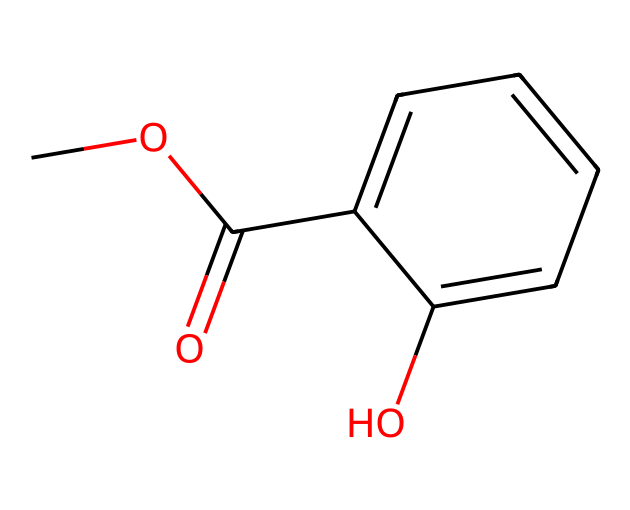How many carbon atoms are present in methyl salicylate? The SMILES representation indicates that there are six carbon atoms in the overall structure. Each "C" represents a carbon atom, and counting them results in a total of six.
Answer: six What functional groups are present in methyl salicylate? Upon analyzing the structure, we can see that there is an ester group (indicated by the COO link) and a hydroxyl group (–OH) stemming from the aromatic ring, classifying it as a phenolic compound as well.
Answer: ester and hydroxyl How many oxygen atoms are in methyl salicylate? The SMILES representation includes the letters "O" which represent oxygen atoms. In this case, there are two oxygen atoms present: one in the ester group and one in the hydroxyl group.
Answer: two Which part of the molecule indicates its aromatic nature? The six-membered carbon ring (C1=CC=CC=C1) represents the presence of alternating double bonds, a characteristic feature of aromatic compounds. This pi-electron system makes it aromatic.
Answer: carbon ring What is the molecular formula of methyl salicylate? From the counts of the atoms in the molecule (C: 8, H: 8, O: 3), we can derive the molecular formula. Putting these counts together gives us C8H8O3.
Answer: C8H8O3 What does the presence of both ester and hydroxyl functional groups suggest about the properties of methyl salicylate? The presence of both functional groups suggests that methyl salicylate may exhibit both polar and non-polar characteristics, affecting its solubility and interaction with biological tissues, thereby influencing its use in traditional remedies.
Answer: polar and non-polar What is the significance of methyl salicylate in herbal remedies? Methyl salicylate is known for its analgesic and anti-inflammatory properties, making it a common constituent in topical pain relief formulations and traditional herbal therapies.
Answer: analgesic and anti-inflammatory 